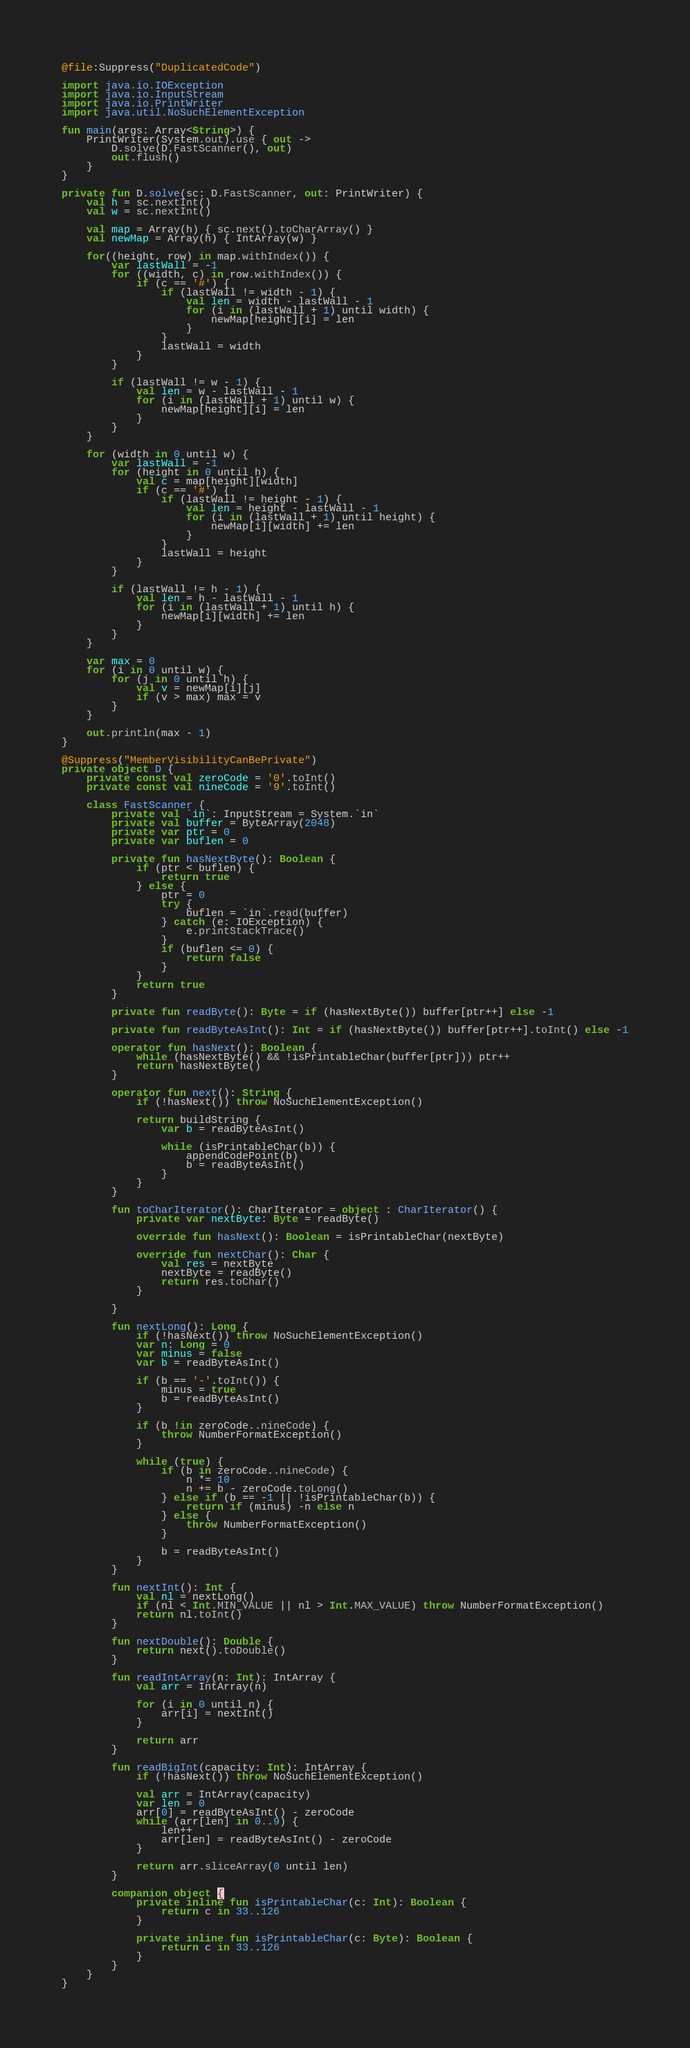<code> <loc_0><loc_0><loc_500><loc_500><_Kotlin_>@file:Suppress("DuplicatedCode")

import java.io.IOException
import java.io.InputStream
import java.io.PrintWriter
import java.util.NoSuchElementException

fun main(args: Array<String>) {
    PrintWriter(System.out).use { out ->
        D.solve(D.FastScanner(), out)
        out.flush()
    }
}

private fun D.solve(sc: D.FastScanner, out: PrintWriter) {
    val h = sc.nextInt()
    val w = sc.nextInt()

    val map = Array(h) { sc.next().toCharArray() }
    val newMap = Array(h) { IntArray(w) }

    for((height, row) in map.withIndex()) {
        var lastWall = -1
        for ((width, c) in row.withIndex()) {
            if (c == '#') {
                if (lastWall != width - 1) {
                    val len = width - lastWall - 1
                    for (i in (lastWall + 1) until width) {
                        newMap[height][i] = len
                    }
                }
                lastWall = width
            }
        }

        if (lastWall != w - 1) {
            val len = w - lastWall - 1
            for (i in (lastWall + 1) until w) {
                newMap[height][i] = len
            }
        }
    }

    for (width in 0 until w) {
        var lastWall = -1
        for (height in 0 until h) {
            val c = map[height][width]
            if (c == '#') {
                if (lastWall != height - 1) {
                    val len = height - lastWall - 1
                    for (i in (lastWall + 1) until height) {
                        newMap[i][width] += len
                    }
                }
                lastWall = height
            }
        }

        if (lastWall != h - 1) {
            val len = h - lastWall - 1
            for (i in (lastWall + 1) until h) {
                newMap[i][width] += len
            }
        }
    }

    var max = 0
    for (i in 0 until w) {
        for (j in 0 until h) {
            val v = newMap[i][j]
            if (v > max) max = v
        }
    }

    out.println(max - 1)
}

@Suppress("MemberVisibilityCanBePrivate")
private object D {
    private const val zeroCode = '0'.toInt()
    private const val nineCode = '9'.toInt()

    class FastScanner {
        private val `in`: InputStream = System.`in`
        private val buffer = ByteArray(2048)
        private var ptr = 0
        private var buflen = 0

        private fun hasNextByte(): Boolean {
            if (ptr < buflen) {
                return true
            } else {
                ptr = 0
                try {
                    buflen = `in`.read(buffer)
                } catch (e: IOException) {
                    e.printStackTrace()
                }
                if (buflen <= 0) {
                    return false
                }
            }
            return true
        }

        private fun readByte(): Byte = if (hasNextByte()) buffer[ptr++] else -1

        private fun readByteAsInt(): Int = if (hasNextByte()) buffer[ptr++].toInt() else -1

        operator fun hasNext(): Boolean {
            while (hasNextByte() && !isPrintableChar(buffer[ptr])) ptr++
            return hasNextByte()
        }

        operator fun next(): String {
            if (!hasNext()) throw NoSuchElementException()

            return buildString {
                var b = readByteAsInt()

                while (isPrintableChar(b)) {
                    appendCodePoint(b)
                    b = readByteAsInt()
                }
            }
        }

        fun toCharIterator(): CharIterator = object : CharIterator() {
            private var nextByte: Byte = readByte()

            override fun hasNext(): Boolean = isPrintableChar(nextByte)

            override fun nextChar(): Char {
                val res = nextByte
                nextByte = readByte()
                return res.toChar()
            }

        }

        fun nextLong(): Long {
            if (!hasNext()) throw NoSuchElementException()
            var n: Long = 0
            var minus = false
            var b = readByteAsInt()

            if (b == '-'.toInt()) {
                minus = true
                b = readByteAsInt()
            }

            if (b !in zeroCode..nineCode) {
                throw NumberFormatException()
            }

            while (true) {
                if (b in zeroCode..nineCode) {
                    n *= 10
                    n += b - zeroCode.toLong()
                } else if (b == -1 || !isPrintableChar(b)) {
                    return if (minus) -n else n
                } else {
                    throw NumberFormatException()
                }

                b = readByteAsInt()
            }
        }

        fun nextInt(): Int {
            val nl = nextLong()
            if (nl < Int.MIN_VALUE || nl > Int.MAX_VALUE) throw NumberFormatException()
            return nl.toInt()
        }

        fun nextDouble(): Double {
            return next().toDouble()
        }

        fun readIntArray(n: Int): IntArray {
            val arr = IntArray(n)

            for (i in 0 until n) {
                arr[i] = nextInt()
            }

            return arr
        }

        fun readBigInt(capacity: Int): IntArray {
            if (!hasNext()) throw NoSuchElementException()

            val arr = IntArray(capacity)
            var len = 0
            arr[0] = readByteAsInt() - zeroCode
            while (arr[len] in 0..9) {
                len++
                arr[len] = readByteAsInt() - zeroCode
            }

            return arr.sliceArray(0 until len)
        }

        companion object {
            private inline fun isPrintableChar(c: Int): Boolean {
                return c in 33..126
            }

            private inline fun isPrintableChar(c: Byte): Boolean {
                return c in 33..126
            }
        }
    }
}
</code> 